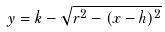Convert formula to latex. <formula><loc_0><loc_0><loc_500><loc_500>y = k - \sqrt { r ^ { 2 } - ( x - h ) ^ { 2 } }</formula> 